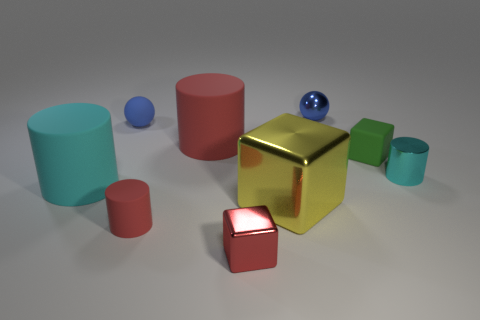What is the shape of the matte object that is the same color as the small matte cylinder?
Offer a terse response. Cylinder. What number of yellow objects are metal objects or small shiny cylinders?
Your answer should be very brief. 1. What is the material of the red cylinder behind the thing that is left of the tiny blue matte thing?
Offer a very short reply. Rubber. Does the tiny green matte thing have the same shape as the red metallic thing?
Provide a short and direct response. Yes. There is another cube that is the same size as the green cube; what color is it?
Give a very brief answer. Red. Are there any matte spheres that have the same color as the small rubber cylinder?
Provide a short and direct response. No. Are there any big cyan metallic balls?
Ensure brevity in your answer.  No. Do the cyan cylinder on the left side of the small red cylinder and the big yellow thing have the same material?
Give a very brief answer. No. The other cylinder that is the same color as the small matte cylinder is what size?
Ensure brevity in your answer.  Large. How many blue rubber things are the same size as the yellow cube?
Provide a succinct answer. 0. 